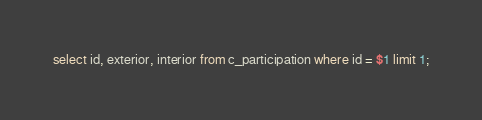<code> <loc_0><loc_0><loc_500><loc_500><_SQL_>select id, exterior, interior from c_participation where id = $1 limit 1;
</code> 